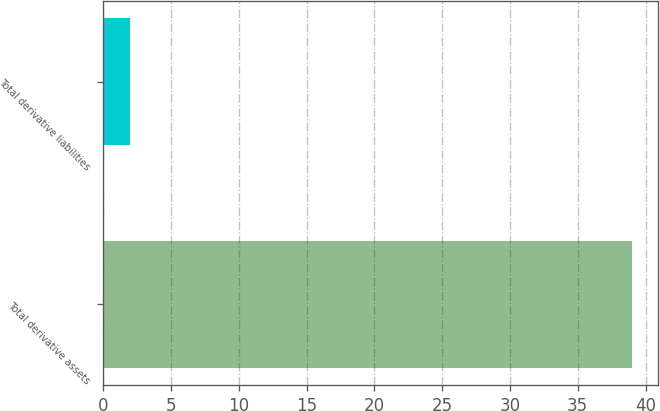<chart> <loc_0><loc_0><loc_500><loc_500><bar_chart><fcel>Total derivative assets<fcel>Total derivative liabilities<nl><fcel>39<fcel>2<nl></chart> 